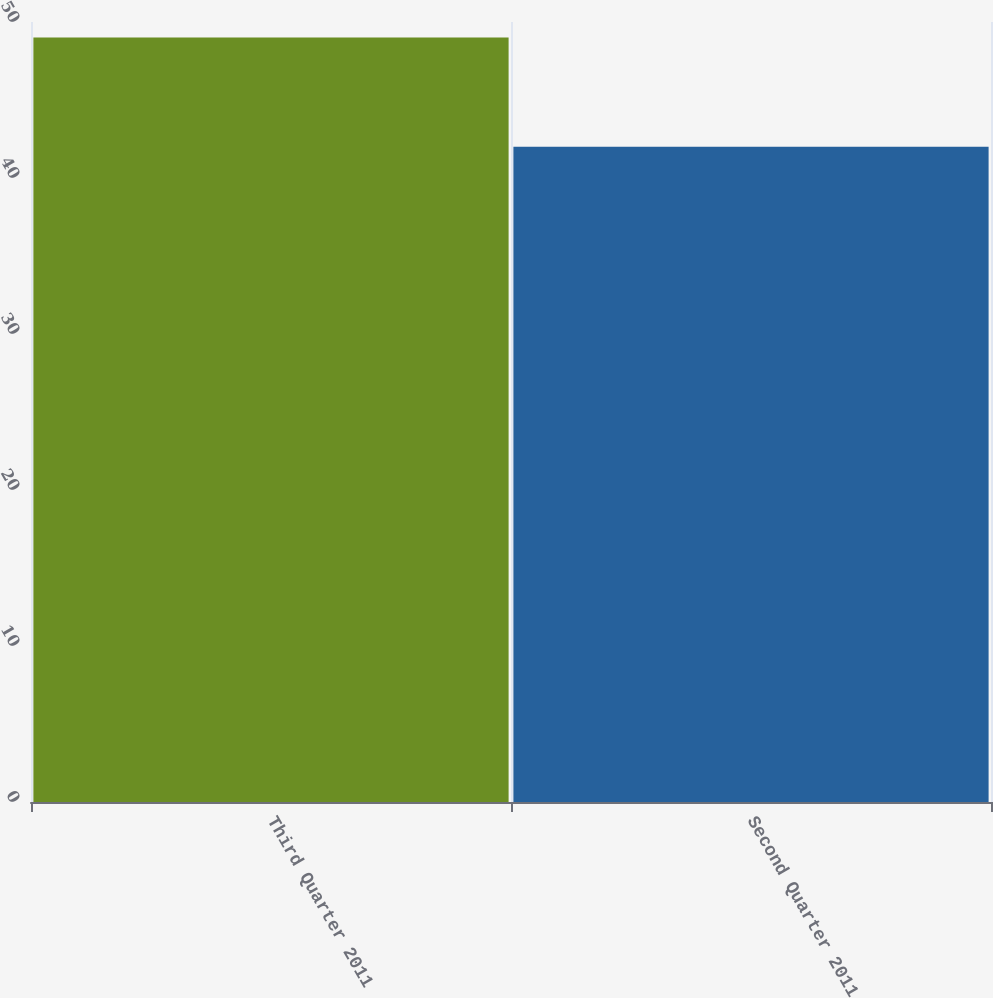<chart> <loc_0><loc_0><loc_500><loc_500><bar_chart><fcel>Third Quarter 2011<fcel>Second Quarter 2011<nl><fcel>49<fcel>42<nl></chart> 